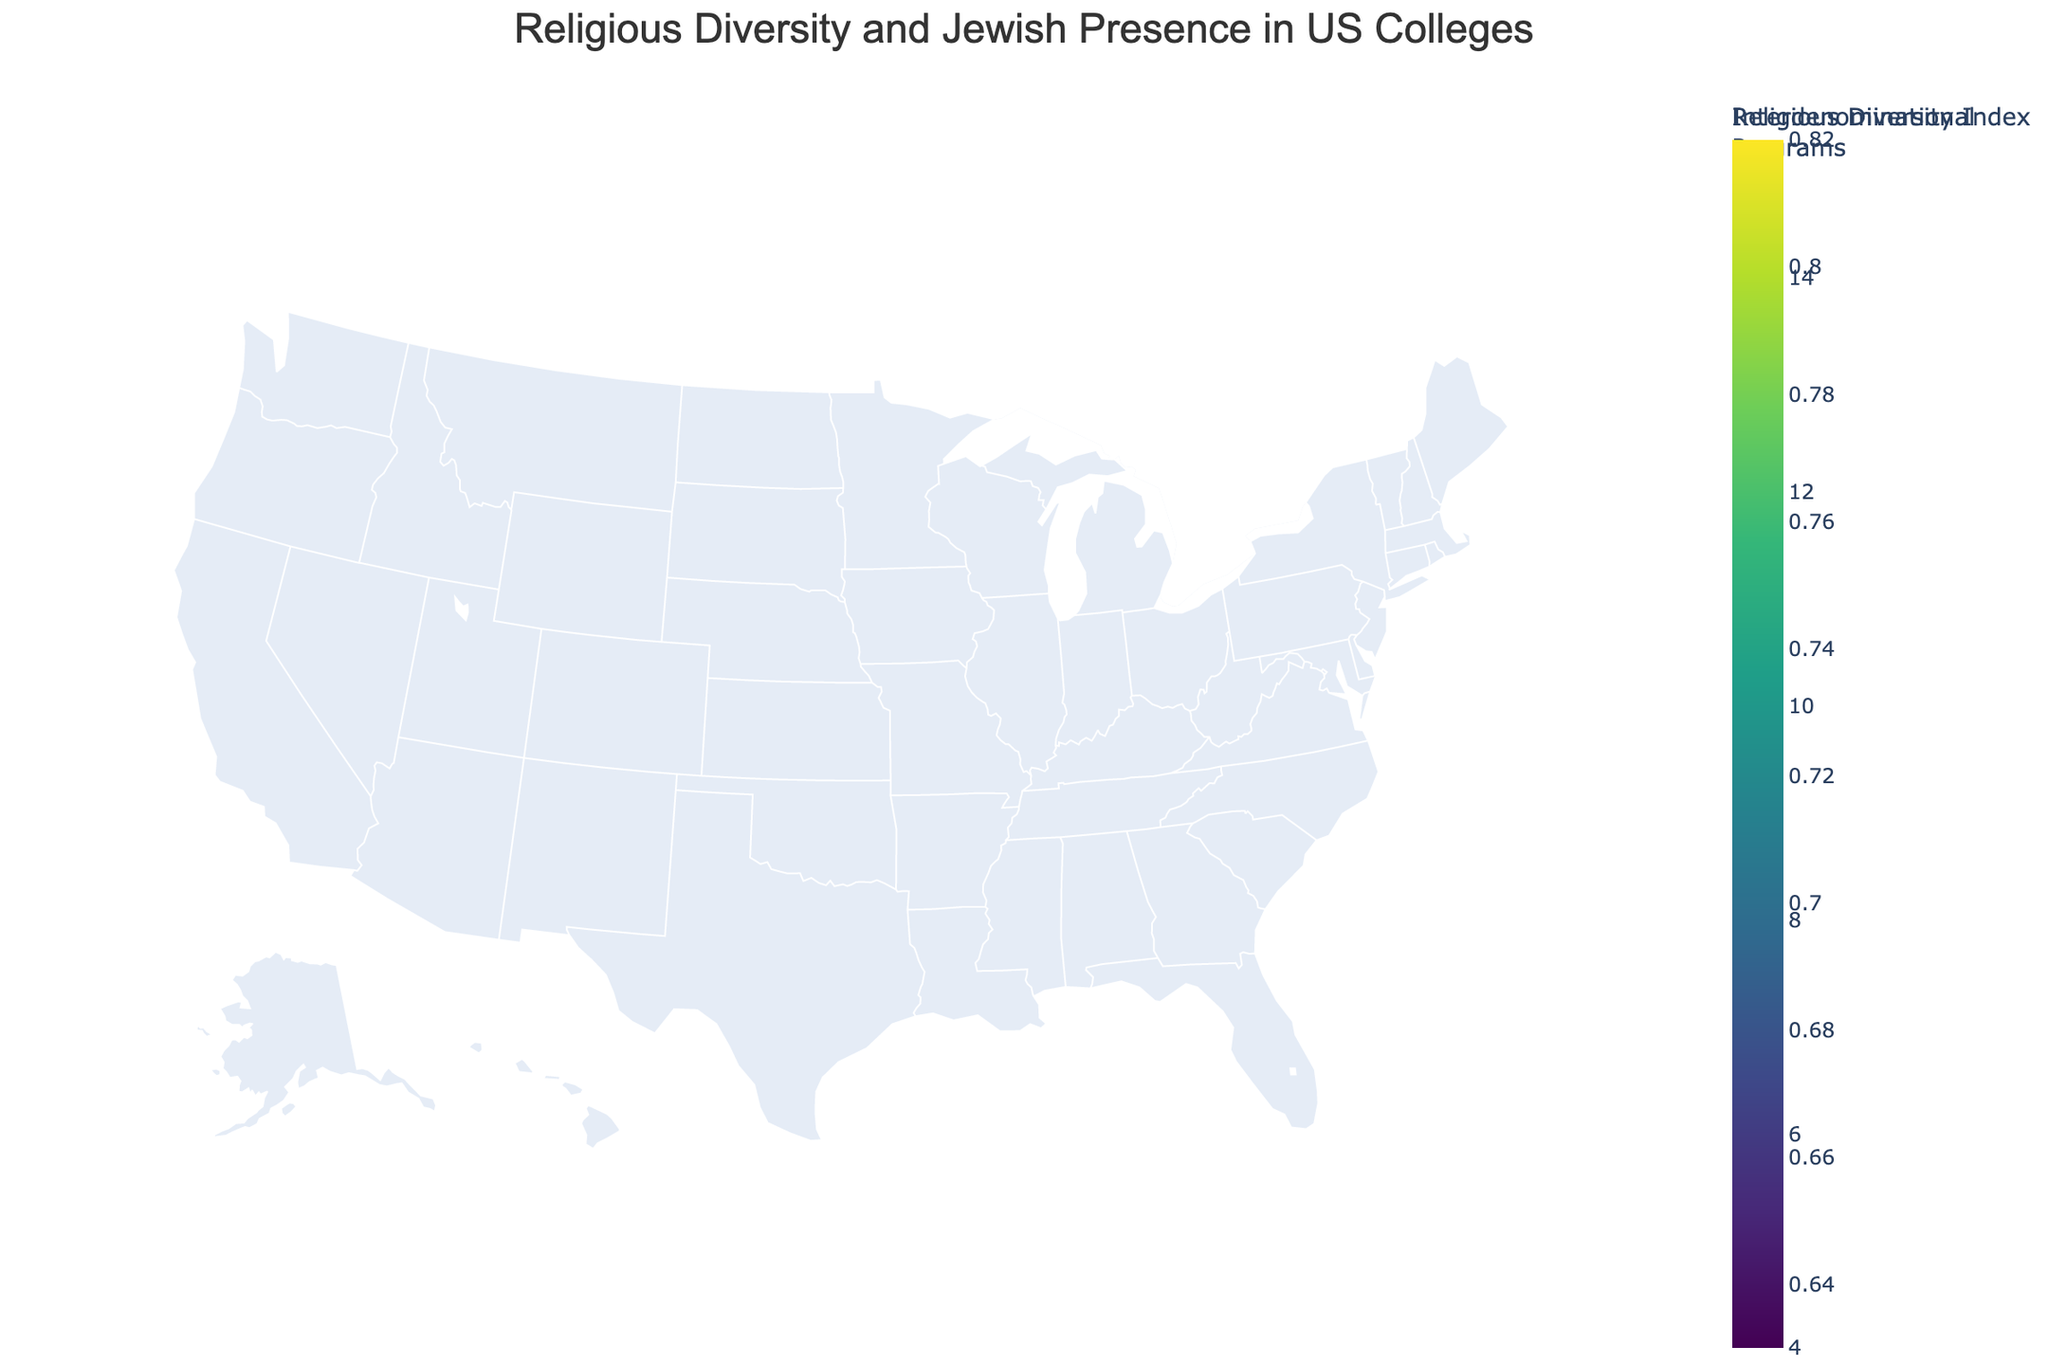What is the total number of states included in the plot? Count the number of unique state names listed in the data.
Answer: 15 Which state has the highest Religious Diversity Index? Identify the state with the highest value in the Religious Diversity Index column from the data.
Answer: New York Which state has the lowest percentage of Jewish students? Find the state with the lowest value in the Jewish Student Percentage column from the data.
Answer: North Carolina What is the relationship between the Jewish Student Percentage and the number of Interdenominational Programs for New York? Check the Jewish Student Percentage (9.7%) and the number of Interdenominational Programs (15) for New York in the hover information.
Answer: New York has 9.7% Jewish students and 15 Interdenominational Programs Is there a state with both high Religious Diversity Index and high Jewish Student Percentage? Examine the data to find a state with both high Religious Diversity Index (above 0.75) and high Jewish Student Percentage (above 5%).
Answer: Massachusetts Which state has more Interdenominational Programs: Florida or Pennsylvania? Compare the number of Interdenominational Programs in Florida (8) to those in Pennsylvania (7).
Answer: Florida What is the average number of Interdenominational Programs across all the states? Sum the values of Interdenominational Programs across all states and divide by the number of states: (12 + 15 + 10 + 8 + 6 + 9 + 7 + 5 + 4 + 6 + 5 + 4 + 7 + 6 + 8) / 15 = 102 / 15.
Answer: 6.8 Which state has a Religious Diversity Index greater than 0.7 but a Jewish Student Percentage less than 5%? Check each state to find one with a Religious Diversity Index above 0.7 and a Jewish Student Percentage below 5%.
Answer: Illinois Compare the Religious Diversity Index between Texas and Colorado. Which one is higher? Look at the Religious Diversity Index values: Texas (0.65) and Colorado (0.69).
Answer: Colorado How many states have a Religious Diversity Index below 0.65? Count the number of states with a Religious Diversity Index value less than 0.65 from the data: Ohio (0.63), Texas (0.65), Georgia (0.66), Michigan (0.67), and Pennsylvania (0.68).
Answer: 1 